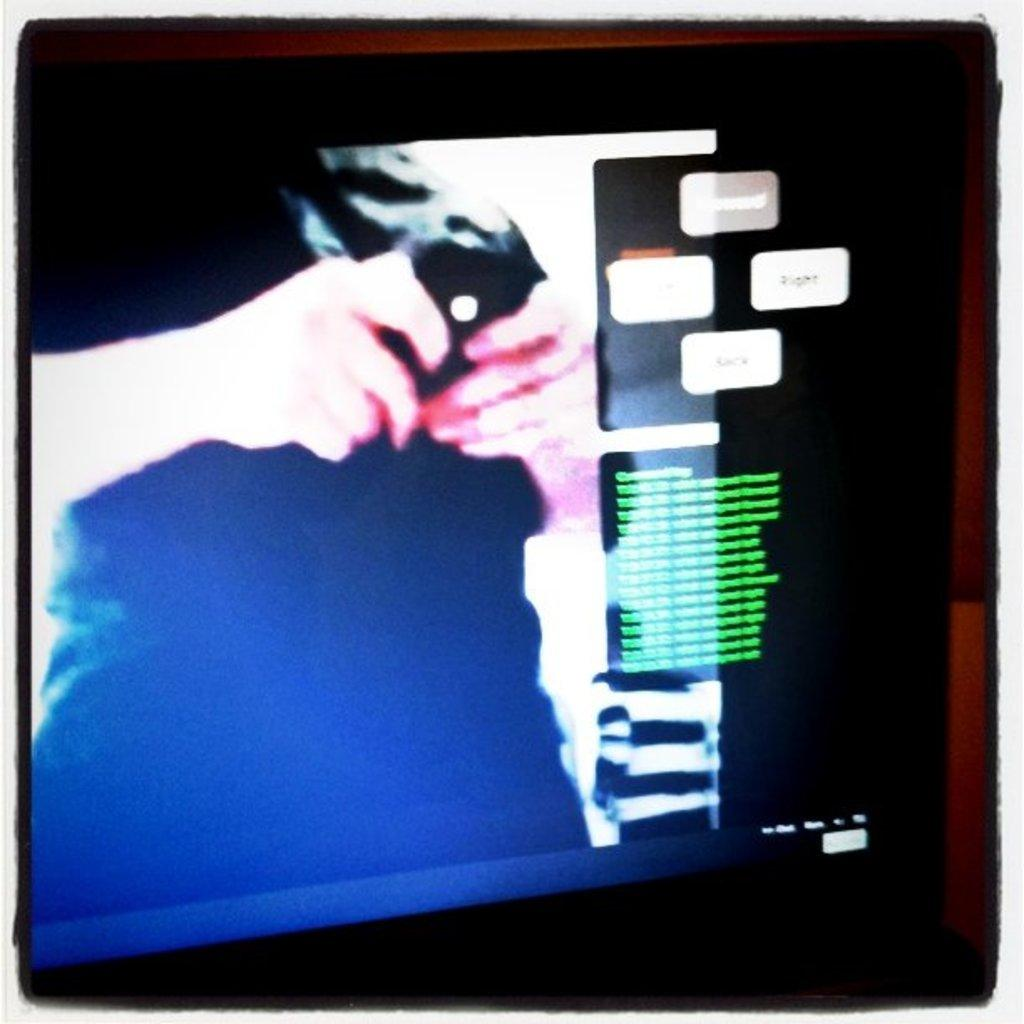What is the main subject of the image? There is a person in the image. What is the person doing in the image? The person is standing. What is the person holding in the image? The person is holding an object on the screen. What can be seen on the screen besides the object being held? There is text on the screen. What type of art can be seen on the tank in the image? There is no tank present in the image, and therefore no art can be seen on it. Is the person wearing a crown in the image? There is no crown visible on the person in the image. 